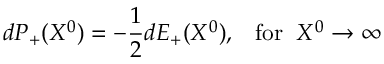Convert formula to latex. <formula><loc_0><loc_0><loc_500><loc_500>d P _ { + } ( X ^ { 0 } ) = - \frac { 1 } { 2 } d E _ { + } ( X ^ { 0 } ) , \, f o r \, X ^ { 0 } \rightarrow \infty</formula> 